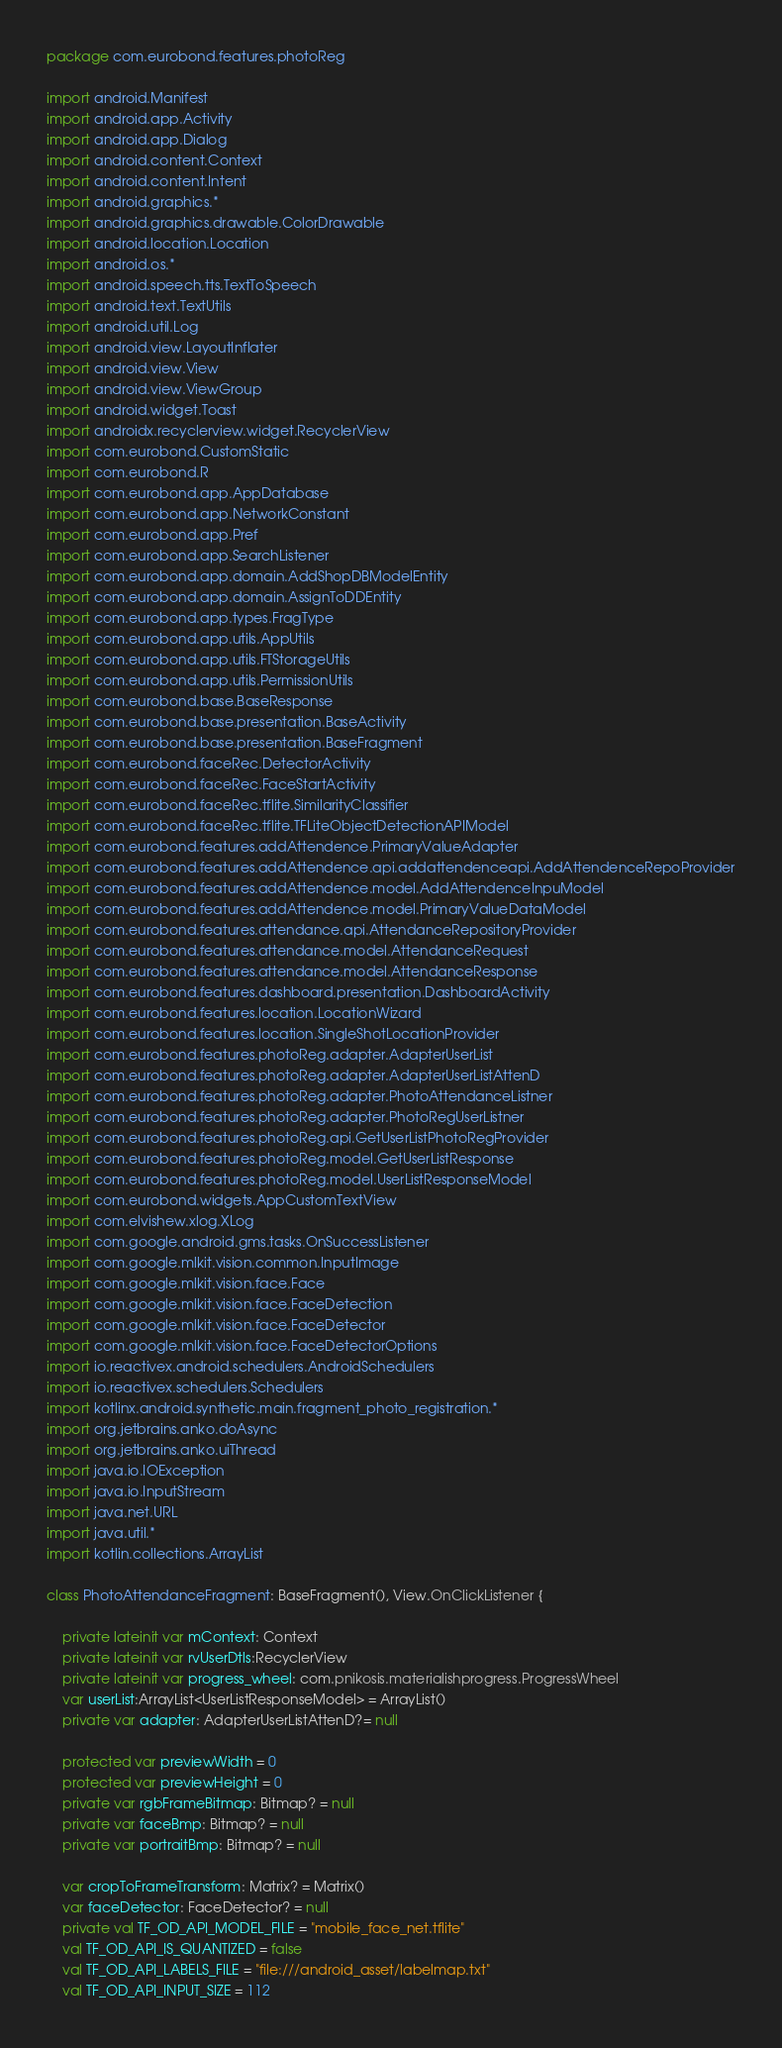Convert code to text. <code><loc_0><loc_0><loc_500><loc_500><_Kotlin_>package com.eurobond.features.photoReg

import android.Manifest
import android.app.Activity
import android.app.Dialog
import android.content.Context
import android.content.Intent
import android.graphics.*
import android.graphics.drawable.ColorDrawable
import android.location.Location
import android.os.*
import android.speech.tts.TextToSpeech
import android.text.TextUtils
import android.util.Log
import android.view.LayoutInflater
import android.view.View
import android.view.ViewGroup
import android.widget.Toast
import androidx.recyclerview.widget.RecyclerView
import com.eurobond.CustomStatic
import com.eurobond.R
import com.eurobond.app.AppDatabase
import com.eurobond.app.NetworkConstant
import com.eurobond.app.Pref
import com.eurobond.app.SearchListener
import com.eurobond.app.domain.AddShopDBModelEntity
import com.eurobond.app.domain.AssignToDDEntity
import com.eurobond.app.types.FragType
import com.eurobond.app.utils.AppUtils
import com.eurobond.app.utils.FTStorageUtils
import com.eurobond.app.utils.PermissionUtils
import com.eurobond.base.BaseResponse
import com.eurobond.base.presentation.BaseActivity
import com.eurobond.base.presentation.BaseFragment
import com.eurobond.faceRec.DetectorActivity
import com.eurobond.faceRec.FaceStartActivity
import com.eurobond.faceRec.tflite.SimilarityClassifier
import com.eurobond.faceRec.tflite.TFLiteObjectDetectionAPIModel
import com.eurobond.features.addAttendence.PrimaryValueAdapter
import com.eurobond.features.addAttendence.api.addattendenceapi.AddAttendenceRepoProvider
import com.eurobond.features.addAttendence.model.AddAttendenceInpuModel
import com.eurobond.features.addAttendence.model.PrimaryValueDataModel
import com.eurobond.features.attendance.api.AttendanceRepositoryProvider
import com.eurobond.features.attendance.model.AttendanceRequest
import com.eurobond.features.attendance.model.AttendanceResponse
import com.eurobond.features.dashboard.presentation.DashboardActivity
import com.eurobond.features.location.LocationWizard
import com.eurobond.features.location.SingleShotLocationProvider
import com.eurobond.features.photoReg.adapter.AdapterUserList
import com.eurobond.features.photoReg.adapter.AdapterUserListAttenD
import com.eurobond.features.photoReg.adapter.PhotoAttendanceListner
import com.eurobond.features.photoReg.adapter.PhotoRegUserListner
import com.eurobond.features.photoReg.api.GetUserListPhotoRegProvider
import com.eurobond.features.photoReg.model.GetUserListResponse
import com.eurobond.features.photoReg.model.UserListResponseModel
import com.eurobond.widgets.AppCustomTextView
import com.elvishew.xlog.XLog
import com.google.android.gms.tasks.OnSuccessListener
import com.google.mlkit.vision.common.InputImage
import com.google.mlkit.vision.face.Face
import com.google.mlkit.vision.face.FaceDetection
import com.google.mlkit.vision.face.FaceDetector
import com.google.mlkit.vision.face.FaceDetectorOptions
import io.reactivex.android.schedulers.AndroidSchedulers
import io.reactivex.schedulers.Schedulers
import kotlinx.android.synthetic.main.fragment_photo_registration.*
import org.jetbrains.anko.doAsync
import org.jetbrains.anko.uiThread
import java.io.IOException
import java.io.InputStream
import java.net.URL
import java.util.*
import kotlin.collections.ArrayList

class PhotoAttendanceFragment: BaseFragment(), View.OnClickListener {

    private lateinit var mContext: Context
    private lateinit var rvUserDtls:RecyclerView
    private lateinit var progress_wheel: com.pnikosis.materialishprogress.ProgressWheel
    var userList:ArrayList<UserListResponseModel> = ArrayList()
    private var adapter: AdapterUserListAttenD?= null

    protected var previewWidth = 0
    protected var previewHeight = 0
    private var rgbFrameBitmap: Bitmap? = null
    private var faceBmp: Bitmap? = null
    private var portraitBmp: Bitmap? = null

    var cropToFrameTransform: Matrix? = Matrix()
    var faceDetector: FaceDetector? = null
    private val TF_OD_API_MODEL_FILE = "mobile_face_net.tflite"
    val TF_OD_API_IS_QUANTIZED = false
    val TF_OD_API_LABELS_FILE = "file:///android_asset/labelmap.txt"
    val TF_OD_API_INPUT_SIZE = 112
</code> 